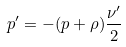Convert formula to latex. <formula><loc_0><loc_0><loc_500><loc_500>p ^ { \prime } = - ( p + \rho ) \frac { \nu ^ { \prime } } { 2 }</formula> 